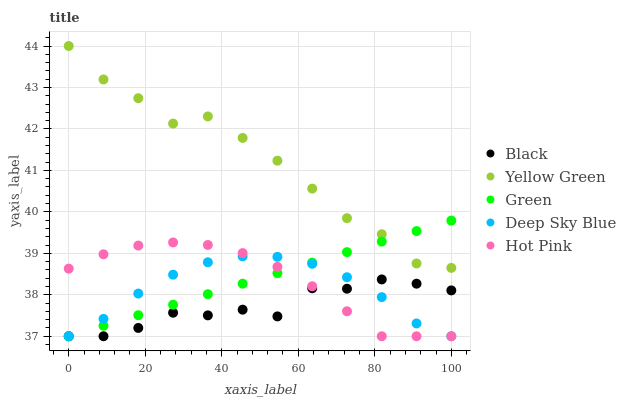Does Black have the minimum area under the curve?
Answer yes or no. Yes. Does Yellow Green have the maximum area under the curve?
Answer yes or no. Yes. Does Hot Pink have the minimum area under the curve?
Answer yes or no. No. Does Hot Pink have the maximum area under the curve?
Answer yes or no. No. Is Green the smoothest?
Answer yes or no. Yes. Is Black the roughest?
Answer yes or no. Yes. Is Hot Pink the smoothest?
Answer yes or no. No. Is Hot Pink the roughest?
Answer yes or no. No. Does Green have the lowest value?
Answer yes or no. Yes. Does Yellow Green have the lowest value?
Answer yes or no. No. Does Yellow Green have the highest value?
Answer yes or no. Yes. Does Hot Pink have the highest value?
Answer yes or no. No. Is Deep Sky Blue less than Yellow Green?
Answer yes or no. Yes. Is Yellow Green greater than Hot Pink?
Answer yes or no. Yes. Does Deep Sky Blue intersect Green?
Answer yes or no. Yes. Is Deep Sky Blue less than Green?
Answer yes or no. No. Is Deep Sky Blue greater than Green?
Answer yes or no. No. Does Deep Sky Blue intersect Yellow Green?
Answer yes or no. No. 